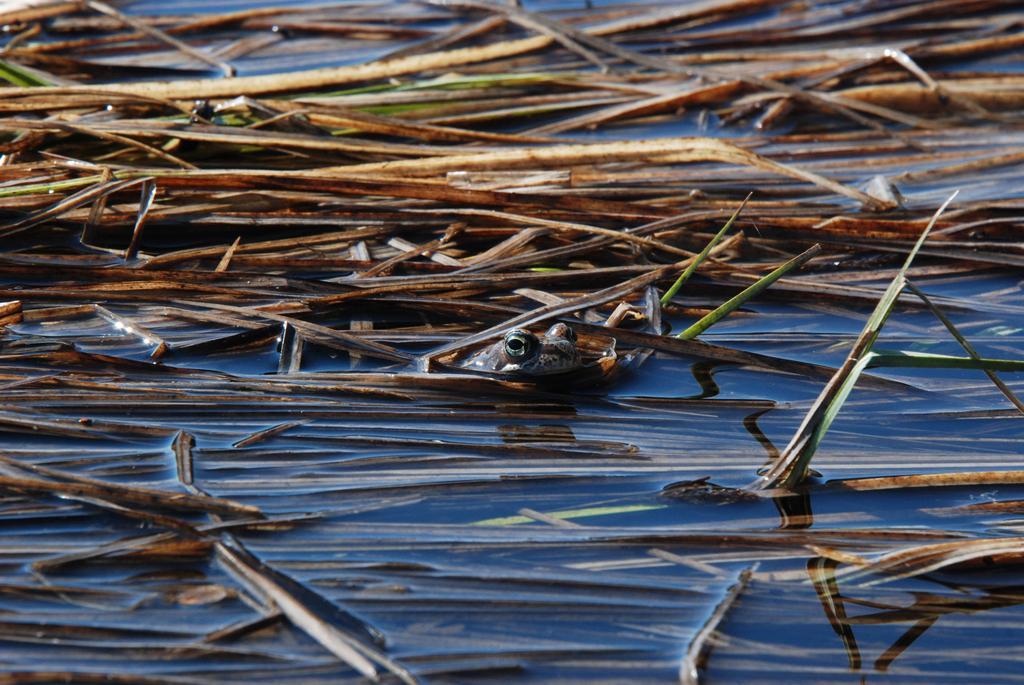Could you give a brief overview of what you see in this image? In this picture there is a river with dried grass and frog. 